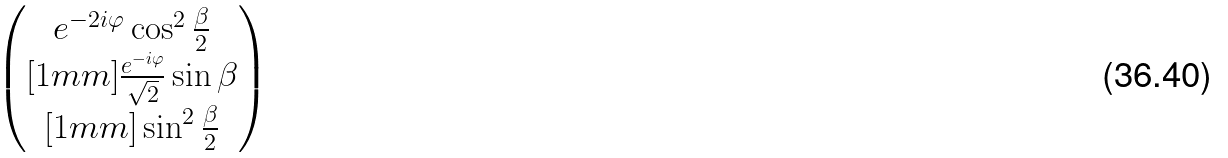<formula> <loc_0><loc_0><loc_500><loc_500>\begin{pmatrix} e ^ { - 2 i \varphi } \cos ^ { 2 } \frac { \beta } { 2 } \\ [ 1 m m ] \frac { e ^ { - i \varphi } } { \sqrt { 2 } } \sin \beta \\ [ 1 m m ] \sin ^ { 2 } \frac { \beta } { 2 } \end{pmatrix}</formula> 